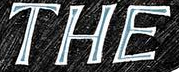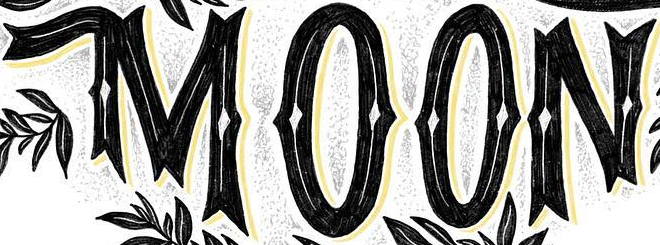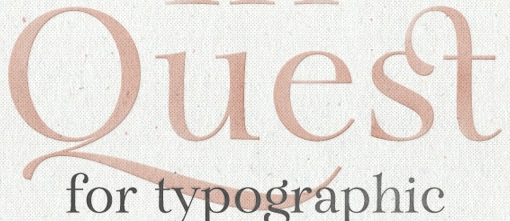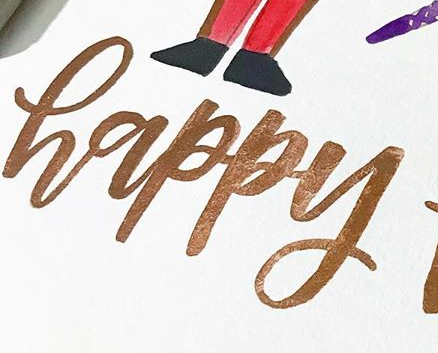Transcribe the words shown in these images in order, separated by a semicolon. THE; MOON; Quest; happy 